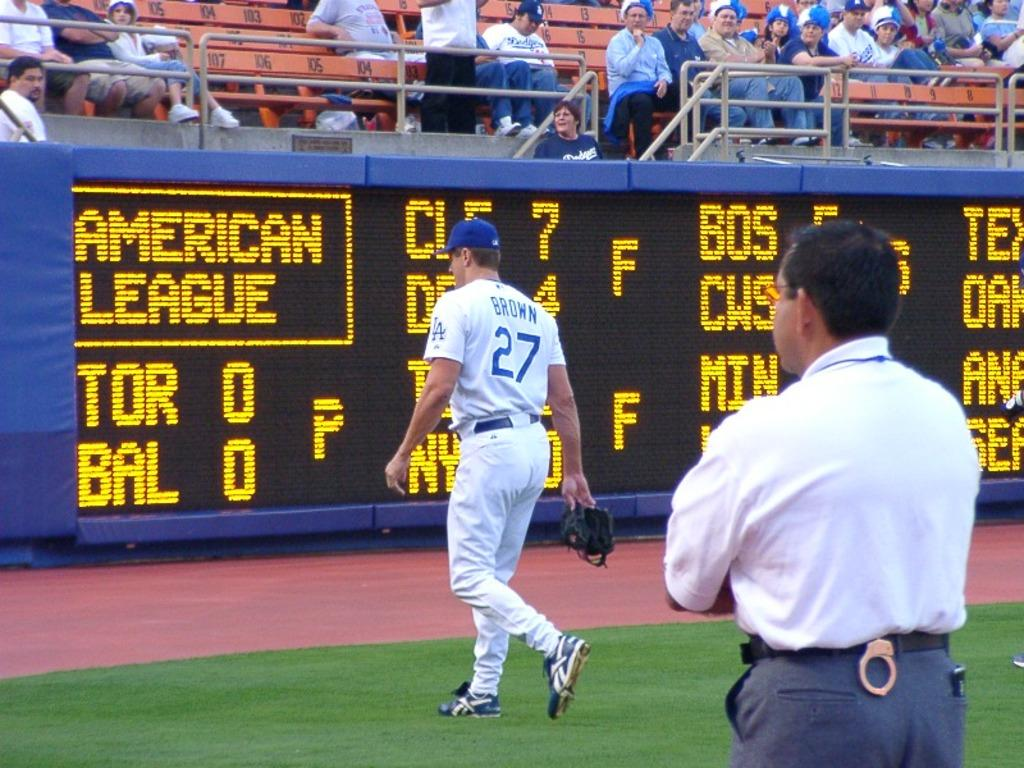<image>
Create a compact narrative representing the image presented. A baseball player with name Brown leaving the field. 